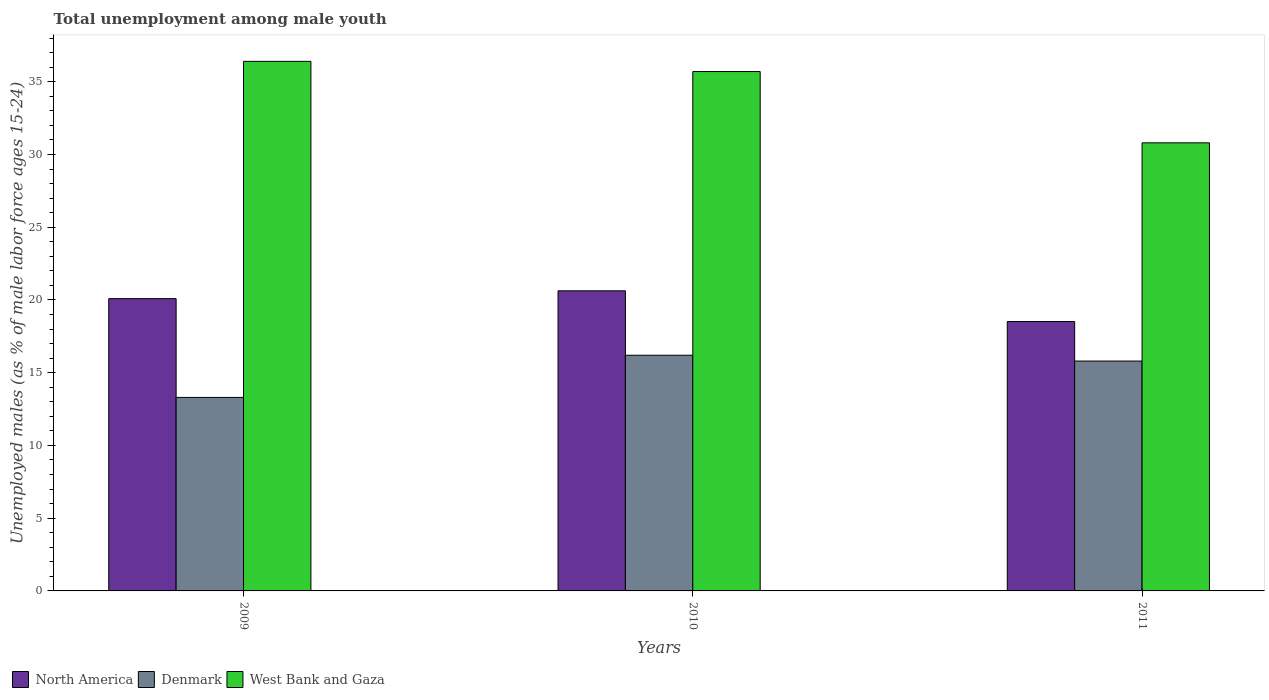How many different coloured bars are there?
Your response must be concise. 3. How many groups of bars are there?
Ensure brevity in your answer.  3. Are the number of bars on each tick of the X-axis equal?
Offer a terse response. Yes. How many bars are there on the 2nd tick from the left?
Your answer should be very brief. 3. How many bars are there on the 3rd tick from the right?
Give a very brief answer. 3. In how many cases, is the number of bars for a given year not equal to the number of legend labels?
Give a very brief answer. 0. What is the percentage of unemployed males in in Denmark in 2011?
Ensure brevity in your answer.  15.8. Across all years, what is the maximum percentage of unemployed males in in West Bank and Gaza?
Give a very brief answer. 36.4. Across all years, what is the minimum percentage of unemployed males in in North America?
Offer a very short reply. 18.52. In which year was the percentage of unemployed males in in West Bank and Gaza maximum?
Offer a very short reply. 2009. In which year was the percentage of unemployed males in in West Bank and Gaza minimum?
Provide a succinct answer. 2011. What is the total percentage of unemployed males in in Denmark in the graph?
Provide a short and direct response. 45.3. What is the difference between the percentage of unemployed males in in West Bank and Gaza in 2010 and that in 2011?
Ensure brevity in your answer.  4.9. What is the difference between the percentage of unemployed males in in Denmark in 2010 and the percentage of unemployed males in in North America in 2009?
Make the answer very short. -3.89. What is the average percentage of unemployed males in in North America per year?
Your response must be concise. 19.75. In the year 2010, what is the difference between the percentage of unemployed males in in West Bank and Gaza and percentage of unemployed males in in North America?
Provide a succinct answer. 15.07. In how many years, is the percentage of unemployed males in in North America greater than 22 %?
Provide a short and direct response. 0. What is the ratio of the percentage of unemployed males in in Denmark in 2010 to that in 2011?
Provide a succinct answer. 1.03. Is the difference between the percentage of unemployed males in in West Bank and Gaza in 2009 and 2010 greater than the difference between the percentage of unemployed males in in North America in 2009 and 2010?
Provide a short and direct response. Yes. What is the difference between the highest and the second highest percentage of unemployed males in in West Bank and Gaza?
Your response must be concise. 0.7. What is the difference between the highest and the lowest percentage of unemployed males in in North America?
Offer a very short reply. 2.11. Is the sum of the percentage of unemployed males in in Denmark in 2010 and 2011 greater than the maximum percentage of unemployed males in in North America across all years?
Ensure brevity in your answer.  Yes. What does the 2nd bar from the left in 2009 represents?
Ensure brevity in your answer.  Denmark. What is the difference between two consecutive major ticks on the Y-axis?
Your response must be concise. 5. Are the values on the major ticks of Y-axis written in scientific E-notation?
Your response must be concise. No. Does the graph contain grids?
Provide a short and direct response. No. How are the legend labels stacked?
Provide a short and direct response. Horizontal. What is the title of the graph?
Offer a very short reply. Total unemployment among male youth. What is the label or title of the Y-axis?
Your answer should be very brief. Unemployed males (as % of male labor force ages 15-24). What is the Unemployed males (as % of male labor force ages 15-24) in North America in 2009?
Provide a succinct answer. 20.09. What is the Unemployed males (as % of male labor force ages 15-24) in Denmark in 2009?
Provide a succinct answer. 13.3. What is the Unemployed males (as % of male labor force ages 15-24) in West Bank and Gaza in 2009?
Provide a succinct answer. 36.4. What is the Unemployed males (as % of male labor force ages 15-24) in North America in 2010?
Offer a very short reply. 20.63. What is the Unemployed males (as % of male labor force ages 15-24) of Denmark in 2010?
Keep it short and to the point. 16.2. What is the Unemployed males (as % of male labor force ages 15-24) of West Bank and Gaza in 2010?
Provide a succinct answer. 35.7. What is the Unemployed males (as % of male labor force ages 15-24) of North America in 2011?
Your answer should be compact. 18.52. What is the Unemployed males (as % of male labor force ages 15-24) in Denmark in 2011?
Make the answer very short. 15.8. What is the Unemployed males (as % of male labor force ages 15-24) in West Bank and Gaza in 2011?
Make the answer very short. 30.8. Across all years, what is the maximum Unemployed males (as % of male labor force ages 15-24) in North America?
Give a very brief answer. 20.63. Across all years, what is the maximum Unemployed males (as % of male labor force ages 15-24) of Denmark?
Provide a short and direct response. 16.2. Across all years, what is the maximum Unemployed males (as % of male labor force ages 15-24) in West Bank and Gaza?
Your response must be concise. 36.4. Across all years, what is the minimum Unemployed males (as % of male labor force ages 15-24) of North America?
Provide a short and direct response. 18.52. Across all years, what is the minimum Unemployed males (as % of male labor force ages 15-24) in Denmark?
Make the answer very short. 13.3. Across all years, what is the minimum Unemployed males (as % of male labor force ages 15-24) of West Bank and Gaza?
Provide a short and direct response. 30.8. What is the total Unemployed males (as % of male labor force ages 15-24) of North America in the graph?
Provide a succinct answer. 59.24. What is the total Unemployed males (as % of male labor force ages 15-24) in Denmark in the graph?
Your answer should be very brief. 45.3. What is the total Unemployed males (as % of male labor force ages 15-24) of West Bank and Gaza in the graph?
Ensure brevity in your answer.  102.9. What is the difference between the Unemployed males (as % of male labor force ages 15-24) of North America in 2009 and that in 2010?
Provide a succinct answer. -0.54. What is the difference between the Unemployed males (as % of male labor force ages 15-24) of North America in 2009 and that in 2011?
Provide a short and direct response. 1.57. What is the difference between the Unemployed males (as % of male labor force ages 15-24) of Denmark in 2009 and that in 2011?
Offer a very short reply. -2.5. What is the difference between the Unemployed males (as % of male labor force ages 15-24) of North America in 2010 and that in 2011?
Give a very brief answer. 2.11. What is the difference between the Unemployed males (as % of male labor force ages 15-24) of North America in 2009 and the Unemployed males (as % of male labor force ages 15-24) of Denmark in 2010?
Offer a very short reply. 3.89. What is the difference between the Unemployed males (as % of male labor force ages 15-24) of North America in 2009 and the Unemployed males (as % of male labor force ages 15-24) of West Bank and Gaza in 2010?
Ensure brevity in your answer.  -15.61. What is the difference between the Unemployed males (as % of male labor force ages 15-24) of Denmark in 2009 and the Unemployed males (as % of male labor force ages 15-24) of West Bank and Gaza in 2010?
Ensure brevity in your answer.  -22.4. What is the difference between the Unemployed males (as % of male labor force ages 15-24) in North America in 2009 and the Unemployed males (as % of male labor force ages 15-24) in Denmark in 2011?
Offer a terse response. 4.29. What is the difference between the Unemployed males (as % of male labor force ages 15-24) in North America in 2009 and the Unemployed males (as % of male labor force ages 15-24) in West Bank and Gaza in 2011?
Provide a short and direct response. -10.71. What is the difference between the Unemployed males (as % of male labor force ages 15-24) of Denmark in 2009 and the Unemployed males (as % of male labor force ages 15-24) of West Bank and Gaza in 2011?
Make the answer very short. -17.5. What is the difference between the Unemployed males (as % of male labor force ages 15-24) in North America in 2010 and the Unemployed males (as % of male labor force ages 15-24) in Denmark in 2011?
Offer a very short reply. 4.83. What is the difference between the Unemployed males (as % of male labor force ages 15-24) in North America in 2010 and the Unemployed males (as % of male labor force ages 15-24) in West Bank and Gaza in 2011?
Your response must be concise. -10.17. What is the difference between the Unemployed males (as % of male labor force ages 15-24) in Denmark in 2010 and the Unemployed males (as % of male labor force ages 15-24) in West Bank and Gaza in 2011?
Offer a very short reply. -14.6. What is the average Unemployed males (as % of male labor force ages 15-24) of North America per year?
Provide a short and direct response. 19.75. What is the average Unemployed males (as % of male labor force ages 15-24) in Denmark per year?
Make the answer very short. 15.1. What is the average Unemployed males (as % of male labor force ages 15-24) in West Bank and Gaza per year?
Provide a succinct answer. 34.3. In the year 2009, what is the difference between the Unemployed males (as % of male labor force ages 15-24) of North America and Unemployed males (as % of male labor force ages 15-24) of Denmark?
Your answer should be very brief. 6.79. In the year 2009, what is the difference between the Unemployed males (as % of male labor force ages 15-24) of North America and Unemployed males (as % of male labor force ages 15-24) of West Bank and Gaza?
Your answer should be compact. -16.31. In the year 2009, what is the difference between the Unemployed males (as % of male labor force ages 15-24) of Denmark and Unemployed males (as % of male labor force ages 15-24) of West Bank and Gaza?
Make the answer very short. -23.1. In the year 2010, what is the difference between the Unemployed males (as % of male labor force ages 15-24) in North America and Unemployed males (as % of male labor force ages 15-24) in Denmark?
Ensure brevity in your answer.  4.43. In the year 2010, what is the difference between the Unemployed males (as % of male labor force ages 15-24) of North America and Unemployed males (as % of male labor force ages 15-24) of West Bank and Gaza?
Your answer should be very brief. -15.07. In the year 2010, what is the difference between the Unemployed males (as % of male labor force ages 15-24) of Denmark and Unemployed males (as % of male labor force ages 15-24) of West Bank and Gaza?
Your answer should be very brief. -19.5. In the year 2011, what is the difference between the Unemployed males (as % of male labor force ages 15-24) of North America and Unemployed males (as % of male labor force ages 15-24) of Denmark?
Keep it short and to the point. 2.72. In the year 2011, what is the difference between the Unemployed males (as % of male labor force ages 15-24) of North America and Unemployed males (as % of male labor force ages 15-24) of West Bank and Gaza?
Provide a succinct answer. -12.28. What is the ratio of the Unemployed males (as % of male labor force ages 15-24) in North America in 2009 to that in 2010?
Offer a terse response. 0.97. What is the ratio of the Unemployed males (as % of male labor force ages 15-24) in Denmark in 2009 to that in 2010?
Your answer should be compact. 0.82. What is the ratio of the Unemployed males (as % of male labor force ages 15-24) in West Bank and Gaza in 2009 to that in 2010?
Provide a succinct answer. 1.02. What is the ratio of the Unemployed males (as % of male labor force ages 15-24) in North America in 2009 to that in 2011?
Your response must be concise. 1.08. What is the ratio of the Unemployed males (as % of male labor force ages 15-24) of Denmark in 2009 to that in 2011?
Offer a very short reply. 0.84. What is the ratio of the Unemployed males (as % of male labor force ages 15-24) in West Bank and Gaza in 2009 to that in 2011?
Give a very brief answer. 1.18. What is the ratio of the Unemployed males (as % of male labor force ages 15-24) in North America in 2010 to that in 2011?
Your answer should be very brief. 1.11. What is the ratio of the Unemployed males (as % of male labor force ages 15-24) in Denmark in 2010 to that in 2011?
Make the answer very short. 1.03. What is the ratio of the Unemployed males (as % of male labor force ages 15-24) in West Bank and Gaza in 2010 to that in 2011?
Ensure brevity in your answer.  1.16. What is the difference between the highest and the second highest Unemployed males (as % of male labor force ages 15-24) of North America?
Ensure brevity in your answer.  0.54. What is the difference between the highest and the second highest Unemployed males (as % of male labor force ages 15-24) in West Bank and Gaza?
Provide a succinct answer. 0.7. What is the difference between the highest and the lowest Unemployed males (as % of male labor force ages 15-24) of North America?
Your answer should be compact. 2.11. What is the difference between the highest and the lowest Unemployed males (as % of male labor force ages 15-24) of Denmark?
Provide a short and direct response. 2.9. 